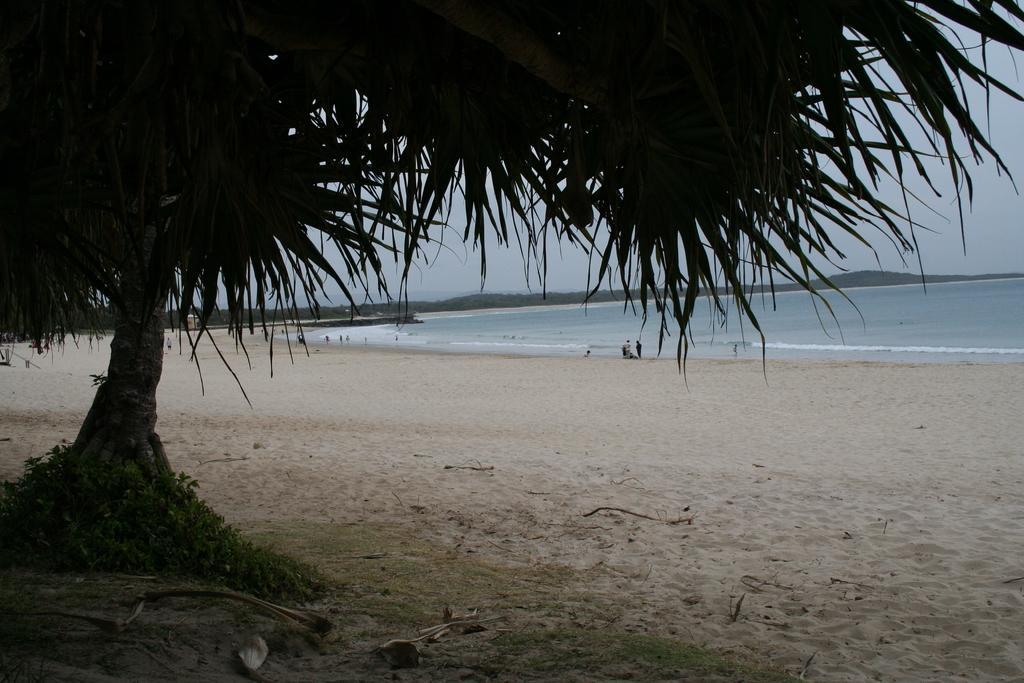Could you give a brief overview of what you see in this image? In this image in the foreground there is one tree, at the bottom there is sand and in the background there is a beach and some persons, trees. At the top of the image there is sky. 